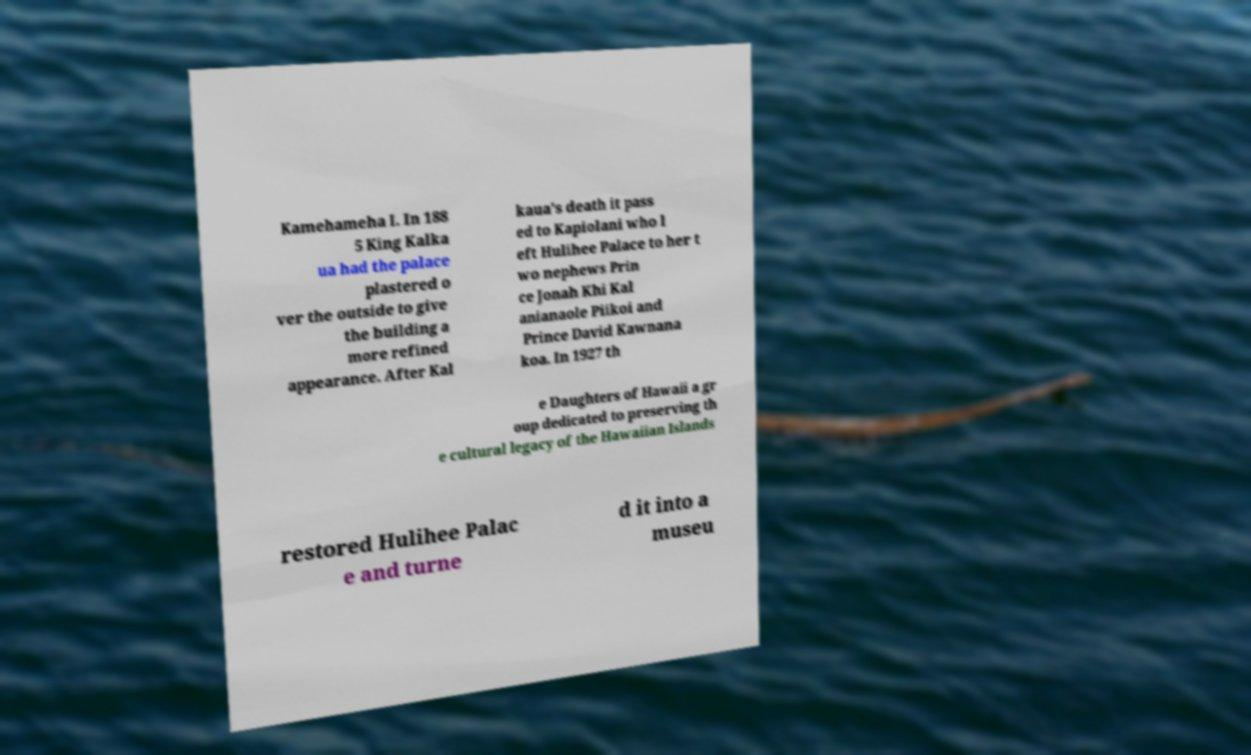Could you extract and type out the text from this image? Kamehameha I. In 188 5 King Kalka ua had the palace plastered o ver the outside to give the building a more refined appearance. After Kal kaua's death it pass ed to Kapiolani who l eft Hulihee Palace to her t wo nephews Prin ce Jonah Khi Kal anianaole Piikoi and Prince David Kawnana koa. In 1927 th e Daughters of Hawaii a gr oup dedicated to preserving th e cultural legacy of the Hawaiian Islands restored Hulihee Palac e and turne d it into a museu 